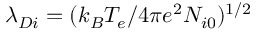<formula> <loc_0><loc_0><loc_500><loc_500>\lambda _ { D i } = ( k _ { B } T _ { e } / 4 \pi e ^ { 2 } N _ { i 0 } ) ^ { 1 / 2 }</formula> 